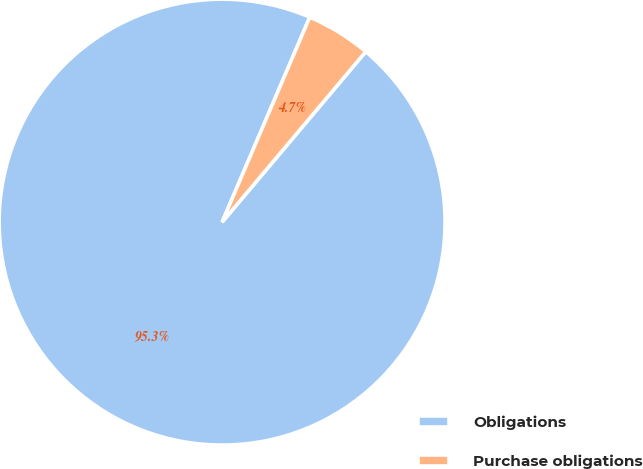Convert chart to OTSL. <chart><loc_0><loc_0><loc_500><loc_500><pie_chart><fcel>Obligations<fcel>Purchase obligations<nl><fcel>95.29%<fcel>4.71%<nl></chart> 